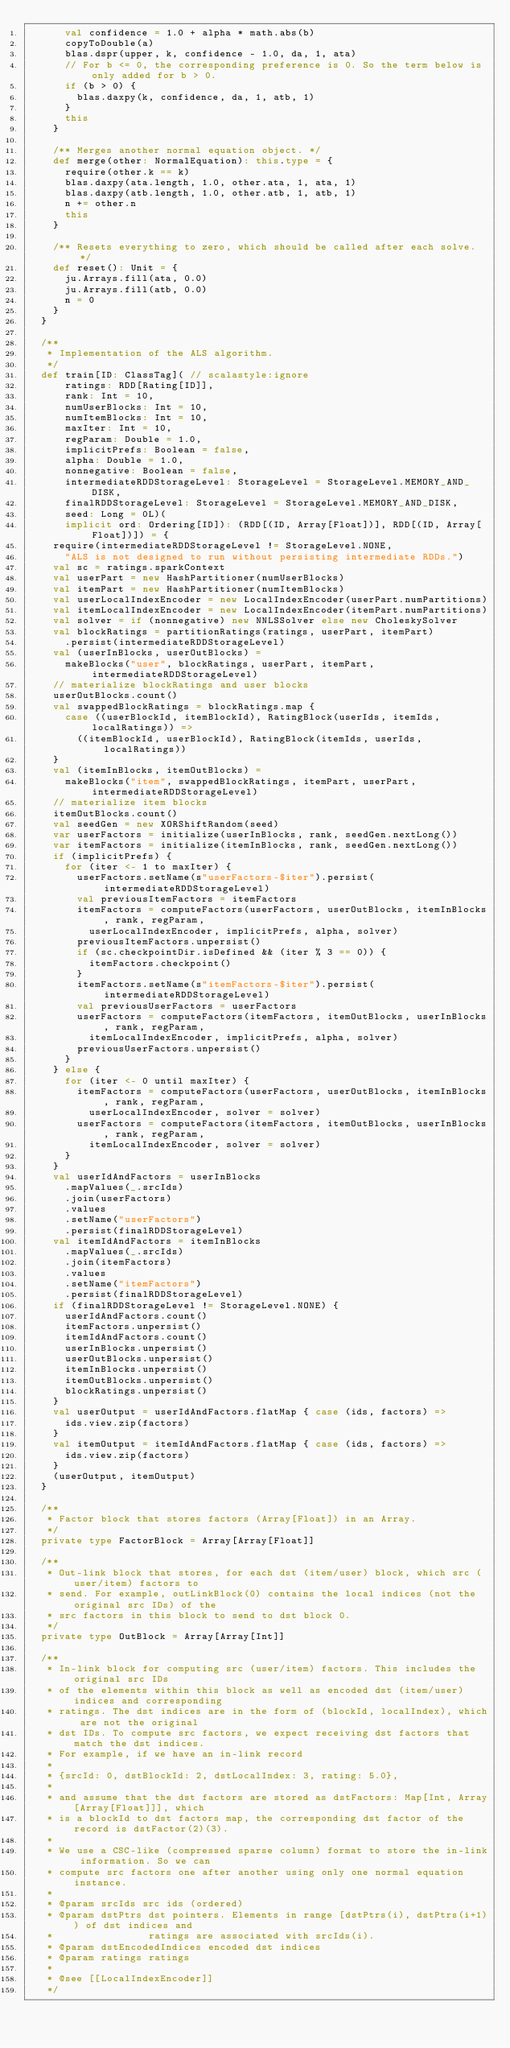Convert code to text. <code><loc_0><loc_0><loc_500><loc_500><_Scala_>      val confidence = 1.0 + alpha * math.abs(b)
      copyToDouble(a)
      blas.dspr(upper, k, confidence - 1.0, da, 1, ata)
      // For b <= 0, the corresponding preference is 0. So the term below is only added for b > 0.
      if (b > 0) {
        blas.daxpy(k, confidence, da, 1, atb, 1)
      }
      this
    }

    /** Merges another normal equation object. */
    def merge(other: NormalEquation): this.type = {
      require(other.k == k)
      blas.daxpy(ata.length, 1.0, other.ata, 1, ata, 1)
      blas.daxpy(atb.length, 1.0, other.atb, 1, atb, 1)
      n += other.n
      this
    }

    /** Resets everything to zero, which should be called after each solve. */
    def reset(): Unit = {
      ju.Arrays.fill(ata, 0.0)
      ju.Arrays.fill(atb, 0.0)
      n = 0
    }
  }

  /**
   * Implementation of the ALS algorithm.
   */
  def train[ID: ClassTag]( // scalastyle:ignore
      ratings: RDD[Rating[ID]],
      rank: Int = 10,
      numUserBlocks: Int = 10,
      numItemBlocks: Int = 10,
      maxIter: Int = 10,
      regParam: Double = 1.0,
      implicitPrefs: Boolean = false,
      alpha: Double = 1.0,
      nonnegative: Boolean = false,
      intermediateRDDStorageLevel: StorageLevel = StorageLevel.MEMORY_AND_DISK,
      finalRDDStorageLevel: StorageLevel = StorageLevel.MEMORY_AND_DISK,
      seed: Long = 0L)(
      implicit ord: Ordering[ID]): (RDD[(ID, Array[Float])], RDD[(ID, Array[Float])]) = {
    require(intermediateRDDStorageLevel != StorageLevel.NONE,
      "ALS is not designed to run without persisting intermediate RDDs.")
    val sc = ratings.sparkContext
    val userPart = new HashPartitioner(numUserBlocks)
    val itemPart = new HashPartitioner(numItemBlocks)
    val userLocalIndexEncoder = new LocalIndexEncoder(userPart.numPartitions)
    val itemLocalIndexEncoder = new LocalIndexEncoder(itemPart.numPartitions)
    val solver = if (nonnegative) new NNLSSolver else new CholeskySolver
    val blockRatings = partitionRatings(ratings, userPart, itemPart)
      .persist(intermediateRDDStorageLevel)
    val (userInBlocks, userOutBlocks) =
      makeBlocks("user", blockRatings, userPart, itemPart, intermediateRDDStorageLevel)
    // materialize blockRatings and user blocks
    userOutBlocks.count()
    val swappedBlockRatings = blockRatings.map {
      case ((userBlockId, itemBlockId), RatingBlock(userIds, itemIds, localRatings)) =>
        ((itemBlockId, userBlockId), RatingBlock(itemIds, userIds, localRatings))
    }
    val (itemInBlocks, itemOutBlocks) =
      makeBlocks("item", swappedBlockRatings, itemPart, userPart, intermediateRDDStorageLevel)
    // materialize item blocks
    itemOutBlocks.count()
    val seedGen = new XORShiftRandom(seed)
    var userFactors = initialize(userInBlocks, rank, seedGen.nextLong())
    var itemFactors = initialize(itemInBlocks, rank, seedGen.nextLong())
    if (implicitPrefs) {
      for (iter <- 1 to maxIter) {
        userFactors.setName(s"userFactors-$iter").persist(intermediateRDDStorageLevel)
        val previousItemFactors = itemFactors
        itemFactors = computeFactors(userFactors, userOutBlocks, itemInBlocks, rank, regParam,
          userLocalIndexEncoder, implicitPrefs, alpha, solver)
        previousItemFactors.unpersist()
        if (sc.checkpointDir.isDefined && (iter % 3 == 0)) {
          itemFactors.checkpoint()
        }
        itemFactors.setName(s"itemFactors-$iter").persist(intermediateRDDStorageLevel)
        val previousUserFactors = userFactors
        userFactors = computeFactors(itemFactors, itemOutBlocks, userInBlocks, rank, regParam,
          itemLocalIndexEncoder, implicitPrefs, alpha, solver)
        previousUserFactors.unpersist()
      }
    } else {
      for (iter <- 0 until maxIter) {
        itemFactors = computeFactors(userFactors, userOutBlocks, itemInBlocks, rank, regParam,
          userLocalIndexEncoder, solver = solver)
        userFactors = computeFactors(itemFactors, itemOutBlocks, userInBlocks, rank, regParam,
          itemLocalIndexEncoder, solver = solver)
      }
    }
    val userIdAndFactors = userInBlocks
      .mapValues(_.srcIds)
      .join(userFactors)
      .values
      .setName("userFactors")
      .persist(finalRDDStorageLevel)
    val itemIdAndFactors = itemInBlocks
      .mapValues(_.srcIds)
      .join(itemFactors)
      .values
      .setName("itemFactors")
      .persist(finalRDDStorageLevel)
    if (finalRDDStorageLevel != StorageLevel.NONE) {
      userIdAndFactors.count()
      itemFactors.unpersist()
      itemIdAndFactors.count()
      userInBlocks.unpersist()
      userOutBlocks.unpersist()
      itemInBlocks.unpersist()
      itemOutBlocks.unpersist()
      blockRatings.unpersist()
    }
    val userOutput = userIdAndFactors.flatMap { case (ids, factors) =>
      ids.view.zip(factors)
    }
    val itemOutput = itemIdAndFactors.flatMap { case (ids, factors) =>
      ids.view.zip(factors)
    }
    (userOutput, itemOutput)
  }

  /**
   * Factor block that stores factors (Array[Float]) in an Array.
   */
  private type FactorBlock = Array[Array[Float]]

  /**
   * Out-link block that stores, for each dst (item/user) block, which src (user/item) factors to
   * send. For example, outLinkBlock(0) contains the local indices (not the original src IDs) of the
   * src factors in this block to send to dst block 0.
   */
  private type OutBlock = Array[Array[Int]]

  /**
   * In-link block for computing src (user/item) factors. This includes the original src IDs
   * of the elements within this block as well as encoded dst (item/user) indices and corresponding
   * ratings. The dst indices are in the form of (blockId, localIndex), which are not the original
   * dst IDs. To compute src factors, we expect receiving dst factors that match the dst indices.
   * For example, if we have an in-link record
   *
   * {srcId: 0, dstBlockId: 2, dstLocalIndex: 3, rating: 5.0},
   *
   * and assume that the dst factors are stored as dstFactors: Map[Int, Array[Array[Float]]], which
   * is a blockId to dst factors map, the corresponding dst factor of the record is dstFactor(2)(3).
   *
   * We use a CSC-like (compressed sparse column) format to store the in-link information. So we can
   * compute src factors one after another using only one normal equation instance.
   *
   * @param srcIds src ids (ordered)
   * @param dstPtrs dst pointers. Elements in range [dstPtrs(i), dstPtrs(i+1)) of dst indices and
   *                ratings are associated with srcIds(i).
   * @param dstEncodedIndices encoded dst indices
   * @param ratings ratings
   *
   * @see [[LocalIndexEncoder]]
   */</code> 